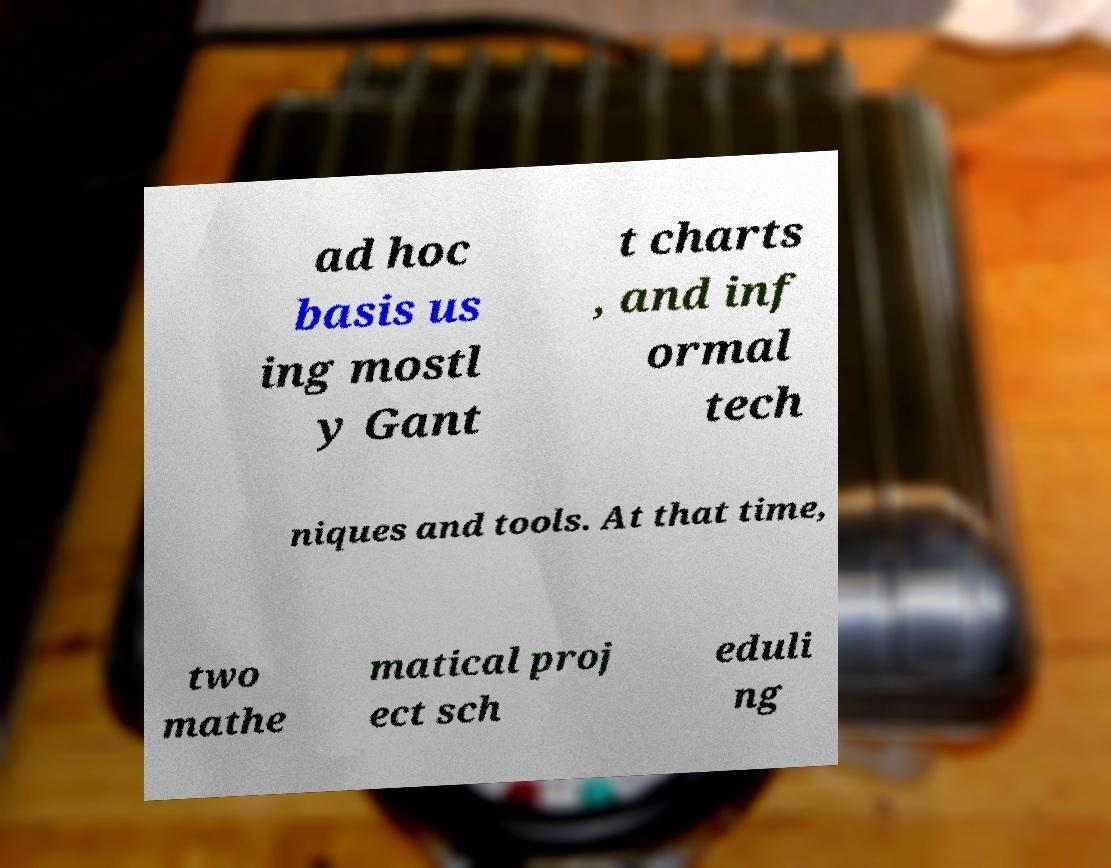What messages or text are displayed in this image? I need them in a readable, typed format. ad hoc basis us ing mostl y Gant t charts , and inf ormal tech niques and tools. At that time, two mathe matical proj ect sch eduli ng 